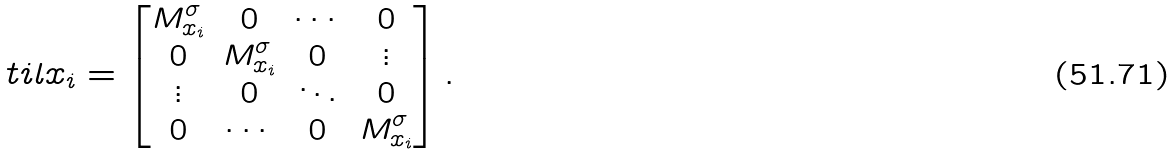Convert formula to latex. <formula><loc_0><loc_0><loc_500><loc_500>\ t i l x _ { i } = \begin{bmatrix} M _ { x _ { i } } ^ { \sigma } & 0 & \cdots & 0 \\ 0 & M _ { x _ { i } } ^ { \sigma } & 0 & \vdots \\ \vdots & 0 & \ddots & 0 \\ 0 & \cdots & 0 & M _ { x _ { i } } ^ { \sigma } \\ \end{bmatrix} .</formula> 